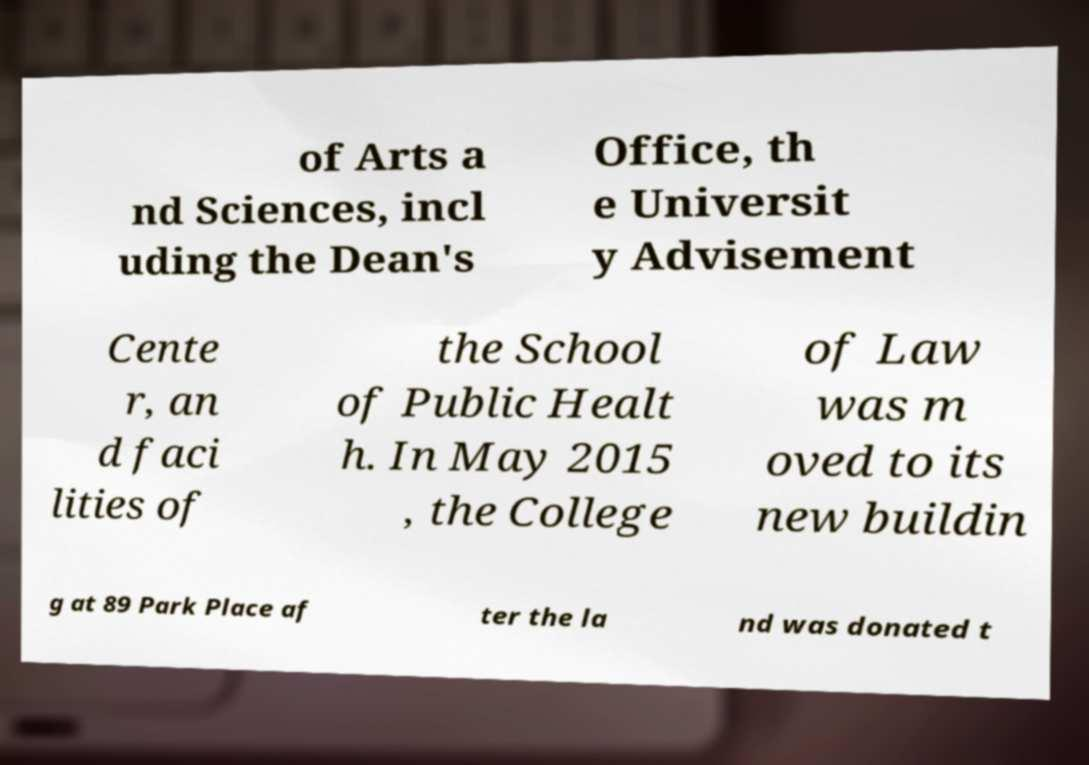Can you accurately transcribe the text from the provided image for me? of Arts a nd Sciences, incl uding the Dean's Office, th e Universit y Advisement Cente r, an d faci lities of the School of Public Healt h. In May 2015 , the College of Law was m oved to its new buildin g at 89 Park Place af ter the la nd was donated t 